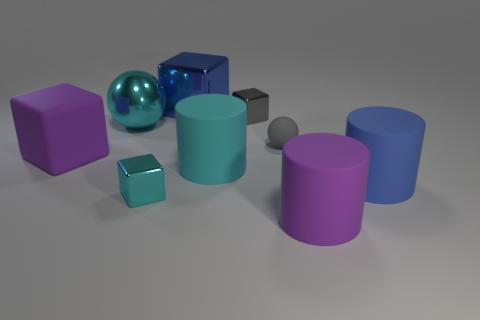Add 1 large blue cylinders. How many objects exist? 10 Subtract all small gray metal cubes. How many cubes are left? 3 Subtract all gray balls. How many balls are left? 1 Subtract 4 cubes. How many cubes are left? 0 Subtract all yellow cubes. How many brown cylinders are left? 0 Subtract 0 red cylinders. How many objects are left? 9 Subtract all cylinders. How many objects are left? 6 Subtract all cyan blocks. Subtract all blue balls. How many blocks are left? 3 Subtract all large blue rubber cylinders. Subtract all large cyan matte objects. How many objects are left? 7 Add 9 big cyan matte cylinders. How many big cyan matte cylinders are left? 10 